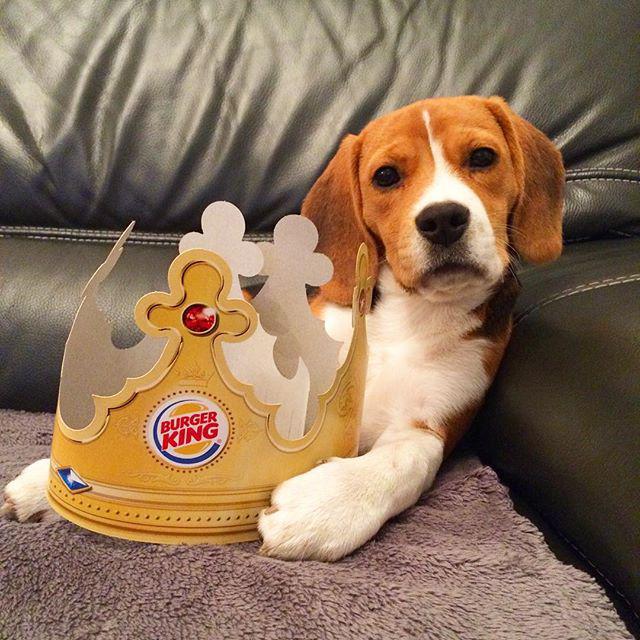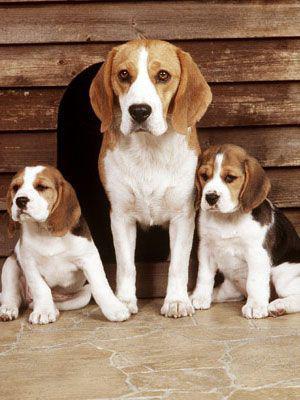The first image is the image on the left, the second image is the image on the right. For the images displayed, is the sentence "There is exactly two dogs in the right image." factually correct? Answer yes or no. No. The first image is the image on the left, the second image is the image on the right. Examine the images to the left and right. Is the description "A total of four beagles are shown, and at least one beagle is posed on an upholstered seat." accurate? Answer yes or no. Yes. 